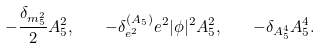Convert formula to latex. <formula><loc_0><loc_0><loc_500><loc_500>- \frac { \delta _ { m _ { 5 } ^ { 2 } } } { 2 } A _ { 5 } ^ { 2 } , \quad - \delta _ { e ^ { 2 } } ^ { ( A _ { 5 } ) } e ^ { 2 } | \phi | ^ { 2 } A _ { 5 } ^ { 2 } , \quad - \delta _ { A _ { 5 } ^ { 4 } } A _ { 5 } ^ { 4 } .</formula> 